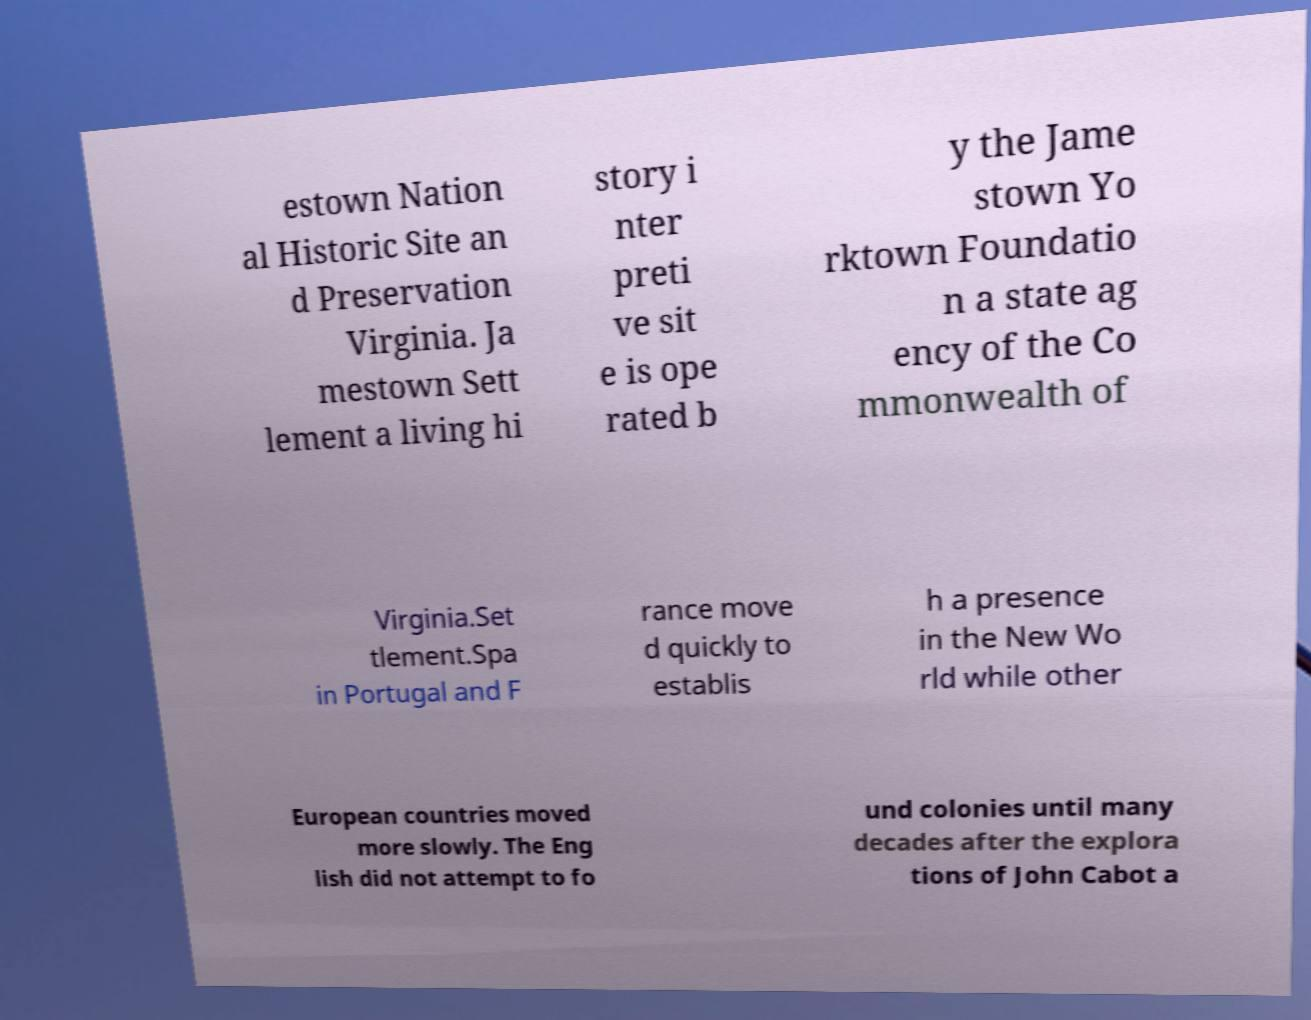Can you read and provide the text displayed in the image?This photo seems to have some interesting text. Can you extract and type it out for me? estown Nation al Historic Site an d Preservation Virginia. Ja mestown Sett lement a living hi story i nter preti ve sit e is ope rated b y the Jame stown Yo rktown Foundatio n a state ag ency of the Co mmonwealth of Virginia.Set tlement.Spa in Portugal and F rance move d quickly to establis h a presence in the New Wo rld while other European countries moved more slowly. The Eng lish did not attempt to fo und colonies until many decades after the explora tions of John Cabot a 